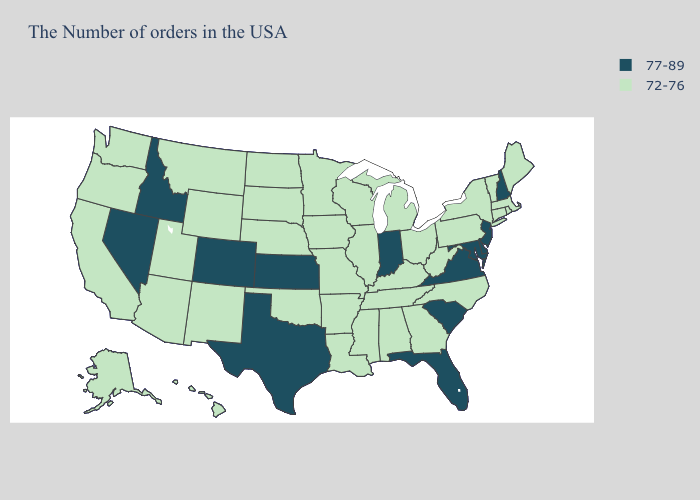What is the value of South Dakota?
Short answer required. 72-76. Name the states that have a value in the range 77-89?
Be succinct. New Hampshire, New Jersey, Delaware, Maryland, Virginia, South Carolina, Florida, Indiana, Kansas, Texas, Colorado, Idaho, Nevada. Name the states that have a value in the range 72-76?
Quick response, please. Maine, Massachusetts, Rhode Island, Vermont, Connecticut, New York, Pennsylvania, North Carolina, West Virginia, Ohio, Georgia, Michigan, Kentucky, Alabama, Tennessee, Wisconsin, Illinois, Mississippi, Louisiana, Missouri, Arkansas, Minnesota, Iowa, Nebraska, Oklahoma, South Dakota, North Dakota, Wyoming, New Mexico, Utah, Montana, Arizona, California, Washington, Oregon, Alaska, Hawaii. Among the states that border Arizona , does California have the highest value?
Quick response, please. No. Name the states that have a value in the range 72-76?
Quick response, please. Maine, Massachusetts, Rhode Island, Vermont, Connecticut, New York, Pennsylvania, North Carolina, West Virginia, Ohio, Georgia, Michigan, Kentucky, Alabama, Tennessee, Wisconsin, Illinois, Mississippi, Louisiana, Missouri, Arkansas, Minnesota, Iowa, Nebraska, Oklahoma, South Dakota, North Dakota, Wyoming, New Mexico, Utah, Montana, Arizona, California, Washington, Oregon, Alaska, Hawaii. Name the states that have a value in the range 72-76?
Give a very brief answer. Maine, Massachusetts, Rhode Island, Vermont, Connecticut, New York, Pennsylvania, North Carolina, West Virginia, Ohio, Georgia, Michigan, Kentucky, Alabama, Tennessee, Wisconsin, Illinois, Mississippi, Louisiana, Missouri, Arkansas, Minnesota, Iowa, Nebraska, Oklahoma, South Dakota, North Dakota, Wyoming, New Mexico, Utah, Montana, Arizona, California, Washington, Oregon, Alaska, Hawaii. What is the value of Missouri?
Give a very brief answer. 72-76. Name the states that have a value in the range 72-76?
Concise answer only. Maine, Massachusetts, Rhode Island, Vermont, Connecticut, New York, Pennsylvania, North Carolina, West Virginia, Ohio, Georgia, Michigan, Kentucky, Alabama, Tennessee, Wisconsin, Illinois, Mississippi, Louisiana, Missouri, Arkansas, Minnesota, Iowa, Nebraska, Oklahoma, South Dakota, North Dakota, Wyoming, New Mexico, Utah, Montana, Arizona, California, Washington, Oregon, Alaska, Hawaii. Among the states that border Nevada , does Idaho have the lowest value?
Give a very brief answer. No. Name the states that have a value in the range 77-89?
Give a very brief answer. New Hampshire, New Jersey, Delaware, Maryland, Virginia, South Carolina, Florida, Indiana, Kansas, Texas, Colorado, Idaho, Nevada. Does Virginia have the lowest value in the USA?
Be succinct. No. Which states have the lowest value in the USA?
Keep it brief. Maine, Massachusetts, Rhode Island, Vermont, Connecticut, New York, Pennsylvania, North Carolina, West Virginia, Ohio, Georgia, Michigan, Kentucky, Alabama, Tennessee, Wisconsin, Illinois, Mississippi, Louisiana, Missouri, Arkansas, Minnesota, Iowa, Nebraska, Oklahoma, South Dakota, North Dakota, Wyoming, New Mexico, Utah, Montana, Arizona, California, Washington, Oregon, Alaska, Hawaii. Does New Jersey have the highest value in the USA?
Concise answer only. Yes. Does the map have missing data?
Write a very short answer. No. Name the states that have a value in the range 72-76?
Quick response, please. Maine, Massachusetts, Rhode Island, Vermont, Connecticut, New York, Pennsylvania, North Carolina, West Virginia, Ohio, Georgia, Michigan, Kentucky, Alabama, Tennessee, Wisconsin, Illinois, Mississippi, Louisiana, Missouri, Arkansas, Minnesota, Iowa, Nebraska, Oklahoma, South Dakota, North Dakota, Wyoming, New Mexico, Utah, Montana, Arizona, California, Washington, Oregon, Alaska, Hawaii. 